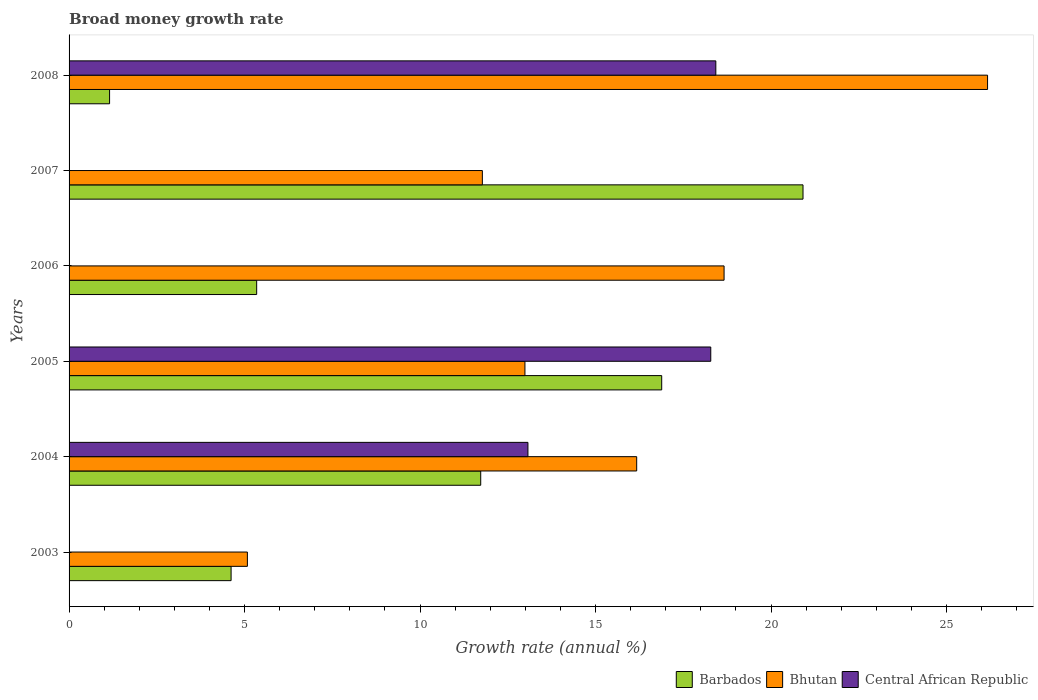How many groups of bars are there?
Keep it short and to the point. 6. How many bars are there on the 5th tick from the top?
Offer a very short reply. 3. How many bars are there on the 1st tick from the bottom?
Make the answer very short. 2. In how many cases, is the number of bars for a given year not equal to the number of legend labels?
Give a very brief answer. 3. What is the growth rate in Central African Republic in 2004?
Provide a succinct answer. 13.07. Across all years, what is the maximum growth rate in Barbados?
Offer a terse response. 20.91. Across all years, what is the minimum growth rate in Bhutan?
Provide a succinct answer. 5.08. In which year was the growth rate in Bhutan maximum?
Your answer should be compact. 2008. What is the total growth rate in Barbados in the graph?
Keep it short and to the point. 60.64. What is the difference between the growth rate in Bhutan in 2003 and that in 2005?
Ensure brevity in your answer.  -7.91. What is the difference between the growth rate in Central African Republic in 2004 and the growth rate in Bhutan in 2005?
Provide a succinct answer. 0.09. What is the average growth rate in Barbados per year?
Keep it short and to the point. 10.11. In the year 2005, what is the difference between the growth rate in Barbados and growth rate in Bhutan?
Your answer should be very brief. 3.9. What is the ratio of the growth rate in Barbados in 2004 to that in 2006?
Provide a short and direct response. 2.19. Is the difference between the growth rate in Barbados in 2003 and 2008 greater than the difference between the growth rate in Bhutan in 2003 and 2008?
Give a very brief answer. Yes. What is the difference between the highest and the second highest growth rate in Central African Republic?
Offer a very short reply. 0.14. What is the difference between the highest and the lowest growth rate in Bhutan?
Your response must be concise. 21.09. In how many years, is the growth rate in Central African Republic greater than the average growth rate in Central African Republic taken over all years?
Your answer should be very brief. 3. Is the sum of the growth rate in Barbados in 2003 and 2006 greater than the maximum growth rate in Bhutan across all years?
Your answer should be compact. No. Are all the bars in the graph horizontal?
Ensure brevity in your answer.  Yes. How many years are there in the graph?
Your response must be concise. 6. Are the values on the major ticks of X-axis written in scientific E-notation?
Make the answer very short. No. Where does the legend appear in the graph?
Give a very brief answer. Bottom right. How are the legend labels stacked?
Make the answer very short. Horizontal. What is the title of the graph?
Offer a terse response. Broad money growth rate. Does "Montenegro" appear as one of the legend labels in the graph?
Make the answer very short. No. What is the label or title of the X-axis?
Your answer should be compact. Growth rate (annual %). What is the label or title of the Y-axis?
Offer a terse response. Years. What is the Growth rate (annual %) in Barbados in 2003?
Provide a succinct answer. 4.62. What is the Growth rate (annual %) in Bhutan in 2003?
Offer a very short reply. 5.08. What is the Growth rate (annual %) of Central African Republic in 2003?
Ensure brevity in your answer.  0. What is the Growth rate (annual %) in Barbados in 2004?
Keep it short and to the point. 11.73. What is the Growth rate (annual %) in Bhutan in 2004?
Provide a succinct answer. 16.17. What is the Growth rate (annual %) in Central African Republic in 2004?
Provide a succinct answer. 13.07. What is the Growth rate (annual %) of Barbados in 2005?
Your response must be concise. 16.89. What is the Growth rate (annual %) of Bhutan in 2005?
Offer a very short reply. 12.99. What is the Growth rate (annual %) of Central African Republic in 2005?
Provide a short and direct response. 18.28. What is the Growth rate (annual %) in Barbados in 2006?
Provide a succinct answer. 5.35. What is the Growth rate (annual %) of Bhutan in 2006?
Offer a very short reply. 18.66. What is the Growth rate (annual %) of Central African Republic in 2006?
Offer a terse response. 0. What is the Growth rate (annual %) in Barbados in 2007?
Give a very brief answer. 20.91. What is the Growth rate (annual %) in Bhutan in 2007?
Provide a succinct answer. 11.78. What is the Growth rate (annual %) in Barbados in 2008?
Provide a succinct answer. 1.15. What is the Growth rate (annual %) of Bhutan in 2008?
Provide a short and direct response. 26.17. What is the Growth rate (annual %) of Central African Republic in 2008?
Offer a very short reply. 18.43. Across all years, what is the maximum Growth rate (annual %) of Barbados?
Provide a succinct answer. 20.91. Across all years, what is the maximum Growth rate (annual %) in Bhutan?
Provide a succinct answer. 26.17. Across all years, what is the maximum Growth rate (annual %) in Central African Republic?
Offer a terse response. 18.43. Across all years, what is the minimum Growth rate (annual %) in Barbados?
Make the answer very short. 1.15. Across all years, what is the minimum Growth rate (annual %) in Bhutan?
Keep it short and to the point. 5.08. What is the total Growth rate (annual %) of Barbados in the graph?
Make the answer very short. 60.64. What is the total Growth rate (annual %) of Bhutan in the graph?
Provide a succinct answer. 90.85. What is the total Growth rate (annual %) of Central African Republic in the graph?
Provide a succinct answer. 49.79. What is the difference between the Growth rate (annual %) in Barbados in 2003 and that in 2004?
Make the answer very short. -7.11. What is the difference between the Growth rate (annual %) of Bhutan in 2003 and that in 2004?
Offer a very short reply. -11.09. What is the difference between the Growth rate (annual %) in Barbados in 2003 and that in 2005?
Provide a succinct answer. -12.27. What is the difference between the Growth rate (annual %) in Bhutan in 2003 and that in 2005?
Provide a succinct answer. -7.91. What is the difference between the Growth rate (annual %) in Barbados in 2003 and that in 2006?
Ensure brevity in your answer.  -0.73. What is the difference between the Growth rate (annual %) of Bhutan in 2003 and that in 2006?
Your response must be concise. -13.58. What is the difference between the Growth rate (annual %) of Barbados in 2003 and that in 2007?
Your answer should be very brief. -16.3. What is the difference between the Growth rate (annual %) of Bhutan in 2003 and that in 2007?
Give a very brief answer. -6.69. What is the difference between the Growth rate (annual %) in Barbados in 2003 and that in 2008?
Offer a very short reply. 3.46. What is the difference between the Growth rate (annual %) in Bhutan in 2003 and that in 2008?
Your response must be concise. -21.09. What is the difference between the Growth rate (annual %) in Barbados in 2004 and that in 2005?
Your answer should be compact. -5.16. What is the difference between the Growth rate (annual %) of Bhutan in 2004 and that in 2005?
Your answer should be very brief. 3.18. What is the difference between the Growth rate (annual %) of Central African Republic in 2004 and that in 2005?
Give a very brief answer. -5.21. What is the difference between the Growth rate (annual %) in Barbados in 2004 and that in 2006?
Provide a short and direct response. 6.38. What is the difference between the Growth rate (annual %) in Bhutan in 2004 and that in 2006?
Your answer should be compact. -2.49. What is the difference between the Growth rate (annual %) of Barbados in 2004 and that in 2007?
Your response must be concise. -9.18. What is the difference between the Growth rate (annual %) of Bhutan in 2004 and that in 2007?
Your answer should be compact. 4.4. What is the difference between the Growth rate (annual %) of Barbados in 2004 and that in 2008?
Your response must be concise. 10.58. What is the difference between the Growth rate (annual %) of Bhutan in 2004 and that in 2008?
Your answer should be compact. -10. What is the difference between the Growth rate (annual %) of Central African Republic in 2004 and that in 2008?
Provide a succinct answer. -5.35. What is the difference between the Growth rate (annual %) in Barbados in 2005 and that in 2006?
Offer a terse response. 11.54. What is the difference between the Growth rate (annual %) in Bhutan in 2005 and that in 2006?
Make the answer very short. -5.67. What is the difference between the Growth rate (annual %) in Barbados in 2005 and that in 2007?
Keep it short and to the point. -4.03. What is the difference between the Growth rate (annual %) of Bhutan in 2005 and that in 2007?
Provide a short and direct response. 1.21. What is the difference between the Growth rate (annual %) of Barbados in 2005 and that in 2008?
Your response must be concise. 15.73. What is the difference between the Growth rate (annual %) of Bhutan in 2005 and that in 2008?
Keep it short and to the point. -13.18. What is the difference between the Growth rate (annual %) in Central African Republic in 2005 and that in 2008?
Your answer should be very brief. -0.14. What is the difference between the Growth rate (annual %) in Barbados in 2006 and that in 2007?
Ensure brevity in your answer.  -15.57. What is the difference between the Growth rate (annual %) in Bhutan in 2006 and that in 2007?
Your answer should be compact. 6.89. What is the difference between the Growth rate (annual %) in Barbados in 2006 and that in 2008?
Your answer should be very brief. 4.19. What is the difference between the Growth rate (annual %) in Bhutan in 2006 and that in 2008?
Make the answer very short. -7.51. What is the difference between the Growth rate (annual %) of Barbados in 2007 and that in 2008?
Your answer should be very brief. 19.76. What is the difference between the Growth rate (annual %) of Bhutan in 2007 and that in 2008?
Ensure brevity in your answer.  -14.4. What is the difference between the Growth rate (annual %) in Barbados in 2003 and the Growth rate (annual %) in Bhutan in 2004?
Give a very brief answer. -11.56. What is the difference between the Growth rate (annual %) in Barbados in 2003 and the Growth rate (annual %) in Central African Republic in 2004?
Provide a short and direct response. -8.46. What is the difference between the Growth rate (annual %) in Bhutan in 2003 and the Growth rate (annual %) in Central African Republic in 2004?
Your answer should be very brief. -7.99. What is the difference between the Growth rate (annual %) in Barbados in 2003 and the Growth rate (annual %) in Bhutan in 2005?
Your answer should be very brief. -8.37. What is the difference between the Growth rate (annual %) of Barbados in 2003 and the Growth rate (annual %) of Central African Republic in 2005?
Offer a terse response. -13.67. What is the difference between the Growth rate (annual %) in Bhutan in 2003 and the Growth rate (annual %) in Central African Republic in 2005?
Give a very brief answer. -13.2. What is the difference between the Growth rate (annual %) in Barbados in 2003 and the Growth rate (annual %) in Bhutan in 2006?
Offer a very short reply. -14.05. What is the difference between the Growth rate (annual %) of Barbados in 2003 and the Growth rate (annual %) of Bhutan in 2007?
Your response must be concise. -7.16. What is the difference between the Growth rate (annual %) of Barbados in 2003 and the Growth rate (annual %) of Bhutan in 2008?
Your answer should be compact. -21.55. What is the difference between the Growth rate (annual %) in Barbados in 2003 and the Growth rate (annual %) in Central African Republic in 2008?
Give a very brief answer. -13.81. What is the difference between the Growth rate (annual %) of Bhutan in 2003 and the Growth rate (annual %) of Central African Republic in 2008?
Provide a short and direct response. -13.35. What is the difference between the Growth rate (annual %) in Barbados in 2004 and the Growth rate (annual %) in Bhutan in 2005?
Offer a terse response. -1.26. What is the difference between the Growth rate (annual %) of Barbados in 2004 and the Growth rate (annual %) of Central African Republic in 2005?
Your answer should be compact. -6.55. What is the difference between the Growth rate (annual %) of Bhutan in 2004 and the Growth rate (annual %) of Central African Republic in 2005?
Provide a short and direct response. -2.11. What is the difference between the Growth rate (annual %) of Barbados in 2004 and the Growth rate (annual %) of Bhutan in 2006?
Your response must be concise. -6.93. What is the difference between the Growth rate (annual %) of Barbados in 2004 and the Growth rate (annual %) of Bhutan in 2007?
Ensure brevity in your answer.  -0.05. What is the difference between the Growth rate (annual %) in Barbados in 2004 and the Growth rate (annual %) in Bhutan in 2008?
Keep it short and to the point. -14.44. What is the difference between the Growth rate (annual %) in Barbados in 2004 and the Growth rate (annual %) in Central African Republic in 2008?
Your response must be concise. -6.7. What is the difference between the Growth rate (annual %) in Bhutan in 2004 and the Growth rate (annual %) in Central African Republic in 2008?
Give a very brief answer. -2.25. What is the difference between the Growth rate (annual %) of Barbados in 2005 and the Growth rate (annual %) of Bhutan in 2006?
Your response must be concise. -1.78. What is the difference between the Growth rate (annual %) of Barbados in 2005 and the Growth rate (annual %) of Bhutan in 2007?
Offer a terse response. 5.11. What is the difference between the Growth rate (annual %) in Barbados in 2005 and the Growth rate (annual %) in Bhutan in 2008?
Offer a terse response. -9.29. What is the difference between the Growth rate (annual %) in Barbados in 2005 and the Growth rate (annual %) in Central African Republic in 2008?
Keep it short and to the point. -1.54. What is the difference between the Growth rate (annual %) of Bhutan in 2005 and the Growth rate (annual %) of Central African Republic in 2008?
Ensure brevity in your answer.  -5.44. What is the difference between the Growth rate (annual %) of Barbados in 2006 and the Growth rate (annual %) of Bhutan in 2007?
Offer a very short reply. -6.43. What is the difference between the Growth rate (annual %) of Barbados in 2006 and the Growth rate (annual %) of Bhutan in 2008?
Your answer should be very brief. -20.83. What is the difference between the Growth rate (annual %) of Barbados in 2006 and the Growth rate (annual %) of Central African Republic in 2008?
Your answer should be compact. -13.08. What is the difference between the Growth rate (annual %) of Bhutan in 2006 and the Growth rate (annual %) of Central African Republic in 2008?
Your answer should be very brief. 0.24. What is the difference between the Growth rate (annual %) in Barbados in 2007 and the Growth rate (annual %) in Bhutan in 2008?
Your answer should be compact. -5.26. What is the difference between the Growth rate (annual %) of Barbados in 2007 and the Growth rate (annual %) of Central African Republic in 2008?
Offer a very short reply. 2.48. What is the difference between the Growth rate (annual %) in Bhutan in 2007 and the Growth rate (annual %) in Central African Republic in 2008?
Make the answer very short. -6.65. What is the average Growth rate (annual %) in Barbados per year?
Ensure brevity in your answer.  10.11. What is the average Growth rate (annual %) of Bhutan per year?
Your answer should be very brief. 15.14. What is the average Growth rate (annual %) in Central African Republic per year?
Give a very brief answer. 8.3. In the year 2003, what is the difference between the Growth rate (annual %) in Barbados and Growth rate (annual %) in Bhutan?
Give a very brief answer. -0.46. In the year 2004, what is the difference between the Growth rate (annual %) in Barbados and Growth rate (annual %) in Bhutan?
Your answer should be very brief. -4.44. In the year 2004, what is the difference between the Growth rate (annual %) in Barbados and Growth rate (annual %) in Central African Republic?
Make the answer very short. -1.35. In the year 2004, what is the difference between the Growth rate (annual %) in Bhutan and Growth rate (annual %) in Central African Republic?
Offer a very short reply. 3.1. In the year 2005, what is the difference between the Growth rate (annual %) in Barbados and Growth rate (annual %) in Bhutan?
Give a very brief answer. 3.9. In the year 2005, what is the difference between the Growth rate (annual %) of Barbados and Growth rate (annual %) of Central African Republic?
Provide a short and direct response. -1.4. In the year 2005, what is the difference between the Growth rate (annual %) of Bhutan and Growth rate (annual %) of Central African Republic?
Your response must be concise. -5.29. In the year 2006, what is the difference between the Growth rate (annual %) in Barbados and Growth rate (annual %) in Bhutan?
Provide a short and direct response. -13.32. In the year 2007, what is the difference between the Growth rate (annual %) in Barbados and Growth rate (annual %) in Bhutan?
Your answer should be very brief. 9.14. In the year 2008, what is the difference between the Growth rate (annual %) in Barbados and Growth rate (annual %) in Bhutan?
Give a very brief answer. -25.02. In the year 2008, what is the difference between the Growth rate (annual %) of Barbados and Growth rate (annual %) of Central African Republic?
Give a very brief answer. -17.27. In the year 2008, what is the difference between the Growth rate (annual %) of Bhutan and Growth rate (annual %) of Central African Republic?
Make the answer very short. 7.74. What is the ratio of the Growth rate (annual %) in Barbados in 2003 to that in 2004?
Your answer should be compact. 0.39. What is the ratio of the Growth rate (annual %) of Bhutan in 2003 to that in 2004?
Keep it short and to the point. 0.31. What is the ratio of the Growth rate (annual %) in Barbados in 2003 to that in 2005?
Your response must be concise. 0.27. What is the ratio of the Growth rate (annual %) in Bhutan in 2003 to that in 2005?
Your answer should be compact. 0.39. What is the ratio of the Growth rate (annual %) of Barbados in 2003 to that in 2006?
Your response must be concise. 0.86. What is the ratio of the Growth rate (annual %) in Bhutan in 2003 to that in 2006?
Provide a succinct answer. 0.27. What is the ratio of the Growth rate (annual %) in Barbados in 2003 to that in 2007?
Keep it short and to the point. 0.22. What is the ratio of the Growth rate (annual %) of Bhutan in 2003 to that in 2007?
Make the answer very short. 0.43. What is the ratio of the Growth rate (annual %) of Barbados in 2003 to that in 2008?
Ensure brevity in your answer.  4. What is the ratio of the Growth rate (annual %) in Bhutan in 2003 to that in 2008?
Your answer should be compact. 0.19. What is the ratio of the Growth rate (annual %) in Barbados in 2004 to that in 2005?
Provide a short and direct response. 0.69. What is the ratio of the Growth rate (annual %) in Bhutan in 2004 to that in 2005?
Your answer should be very brief. 1.25. What is the ratio of the Growth rate (annual %) in Central African Republic in 2004 to that in 2005?
Offer a terse response. 0.72. What is the ratio of the Growth rate (annual %) of Barbados in 2004 to that in 2006?
Make the answer very short. 2.19. What is the ratio of the Growth rate (annual %) in Bhutan in 2004 to that in 2006?
Provide a succinct answer. 0.87. What is the ratio of the Growth rate (annual %) of Barbados in 2004 to that in 2007?
Provide a succinct answer. 0.56. What is the ratio of the Growth rate (annual %) of Bhutan in 2004 to that in 2007?
Give a very brief answer. 1.37. What is the ratio of the Growth rate (annual %) in Barbados in 2004 to that in 2008?
Give a very brief answer. 10.16. What is the ratio of the Growth rate (annual %) of Bhutan in 2004 to that in 2008?
Ensure brevity in your answer.  0.62. What is the ratio of the Growth rate (annual %) of Central African Republic in 2004 to that in 2008?
Make the answer very short. 0.71. What is the ratio of the Growth rate (annual %) of Barbados in 2005 to that in 2006?
Provide a succinct answer. 3.16. What is the ratio of the Growth rate (annual %) of Bhutan in 2005 to that in 2006?
Offer a terse response. 0.7. What is the ratio of the Growth rate (annual %) of Barbados in 2005 to that in 2007?
Offer a very short reply. 0.81. What is the ratio of the Growth rate (annual %) of Bhutan in 2005 to that in 2007?
Provide a short and direct response. 1.1. What is the ratio of the Growth rate (annual %) of Barbados in 2005 to that in 2008?
Give a very brief answer. 14.63. What is the ratio of the Growth rate (annual %) in Bhutan in 2005 to that in 2008?
Your response must be concise. 0.5. What is the ratio of the Growth rate (annual %) in Barbados in 2006 to that in 2007?
Your response must be concise. 0.26. What is the ratio of the Growth rate (annual %) in Bhutan in 2006 to that in 2007?
Ensure brevity in your answer.  1.58. What is the ratio of the Growth rate (annual %) of Barbados in 2006 to that in 2008?
Provide a short and direct response. 4.63. What is the ratio of the Growth rate (annual %) in Bhutan in 2006 to that in 2008?
Offer a terse response. 0.71. What is the ratio of the Growth rate (annual %) of Barbados in 2007 to that in 2008?
Make the answer very short. 18.12. What is the ratio of the Growth rate (annual %) in Bhutan in 2007 to that in 2008?
Offer a terse response. 0.45. What is the difference between the highest and the second highest Growth rate (annual %) of Barbados?
Ensure brevity in your answer.  4.03. What is the difference between the highest and the second highest Growth rate (annual %) in Bhutan?
Your answer should be very brief. 7.51. What is the difference between the highest and the second highest Growth rate (annual %) of Central African Republic?
Give a very brief answer. 0.14. What is the difference between the highest and the lowest Growth rate (annual %) of Barbados?
Your answer should be compact. 19.76. What is the difference between the highest and the lowest Growth rate (annual %) in Bhutan?
Ensure brevity in your answer.  21.09. What is the difference between the highest and the lowest Growth rate (annual %) in Central African Republic?
Provide a short and direct response. 18.43. 